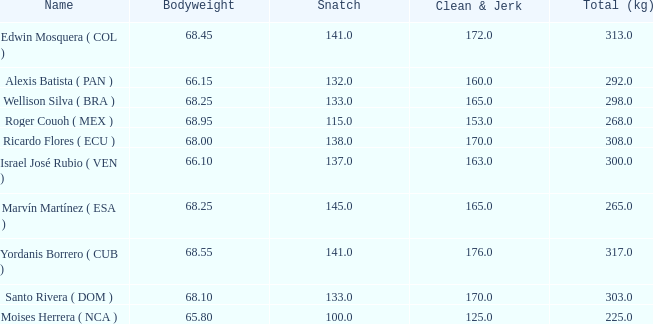Which Total (kg) has a Clean & Jerk smaller than 153, and a Snatch smaller than 100? None. 